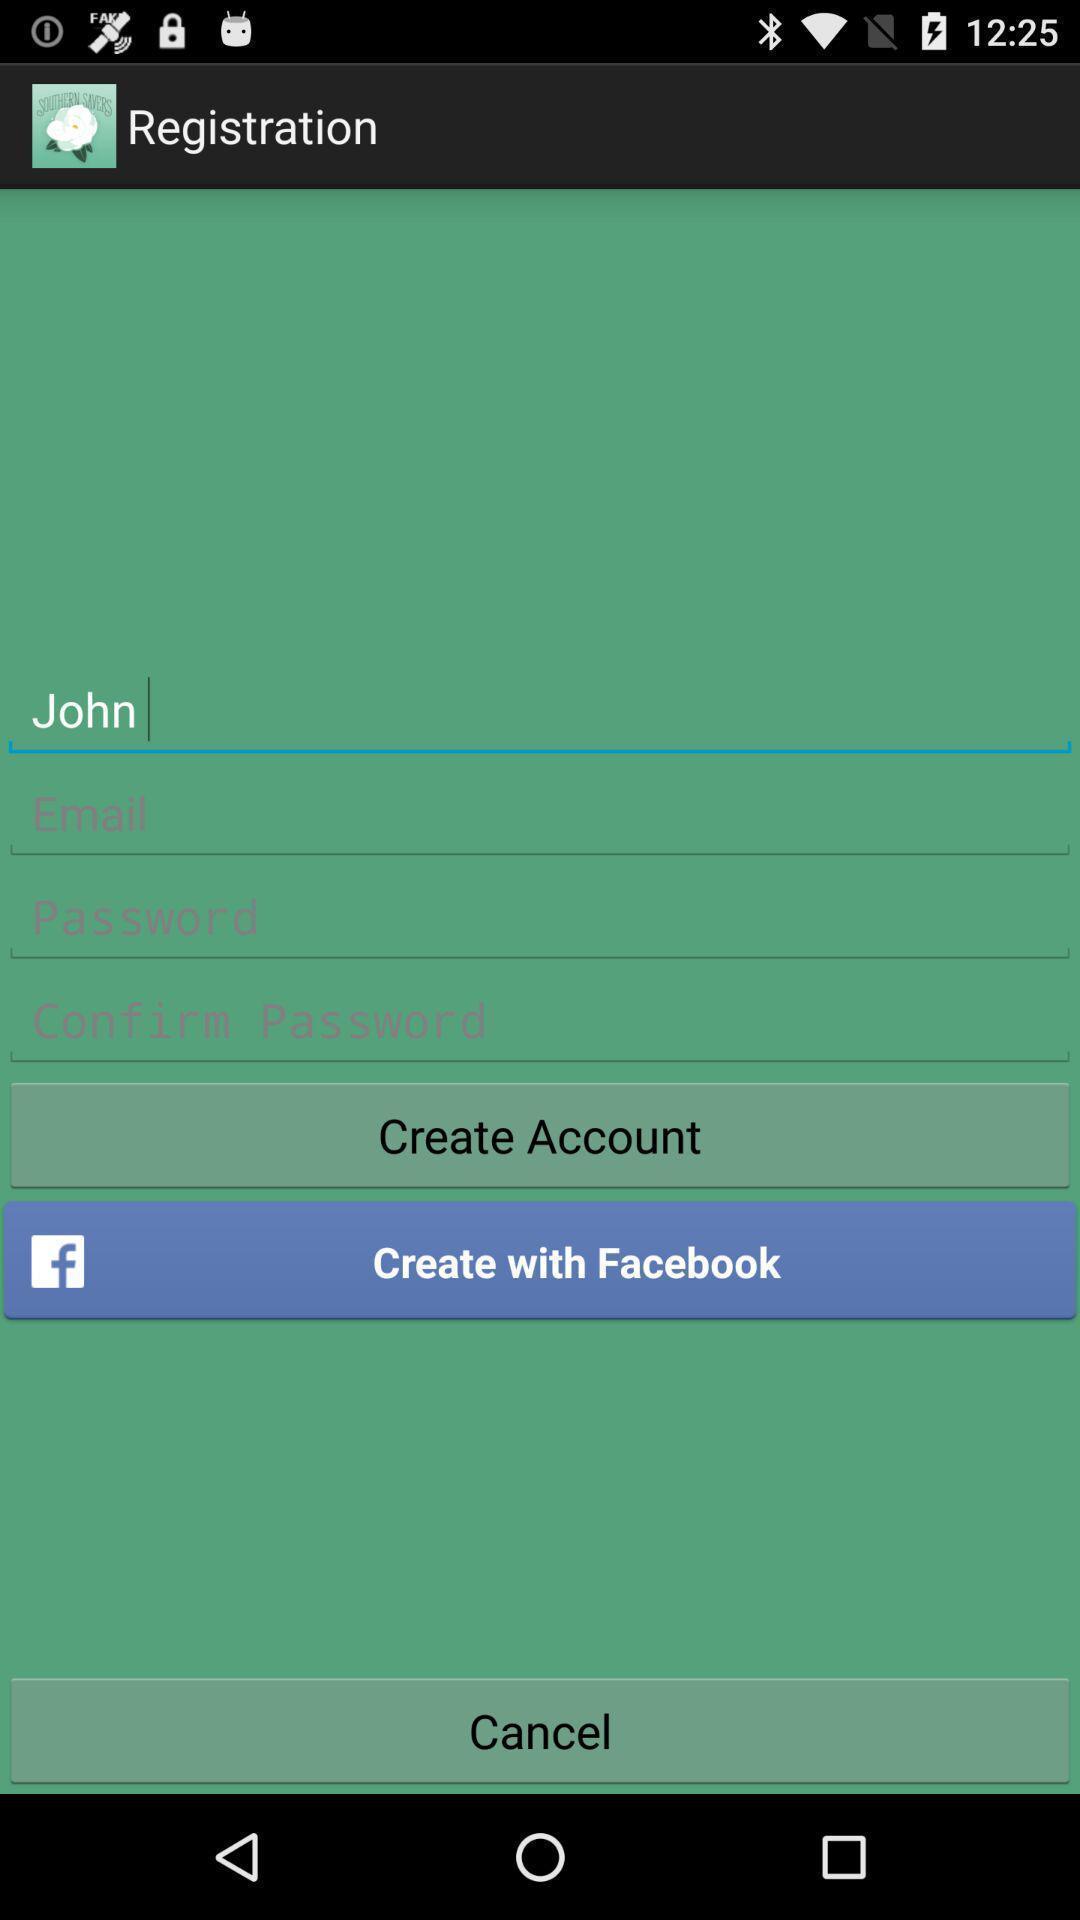Provide a detailed account of this screenshot. Welcome to the sign in page. 